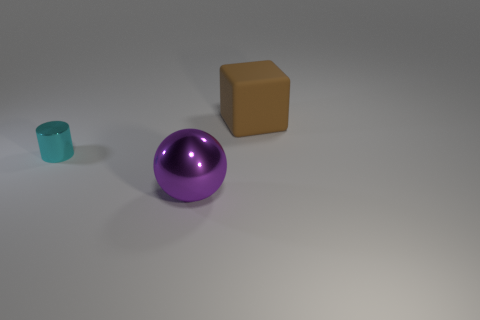Add 2 tiny brown matte things. How many objects exist? 5 Subtract all spheres. How many objects are left? 2 Subtract 0 yellow cylinders. How many objects are left? 3 Subtract all small blue spheres. Subtract all purple balls. How many objects are left? 2 Add 3 matte blocks. How many matte blocks are left? 4 Add 3 purple shiny things. How many purple shiny things exist? 4 